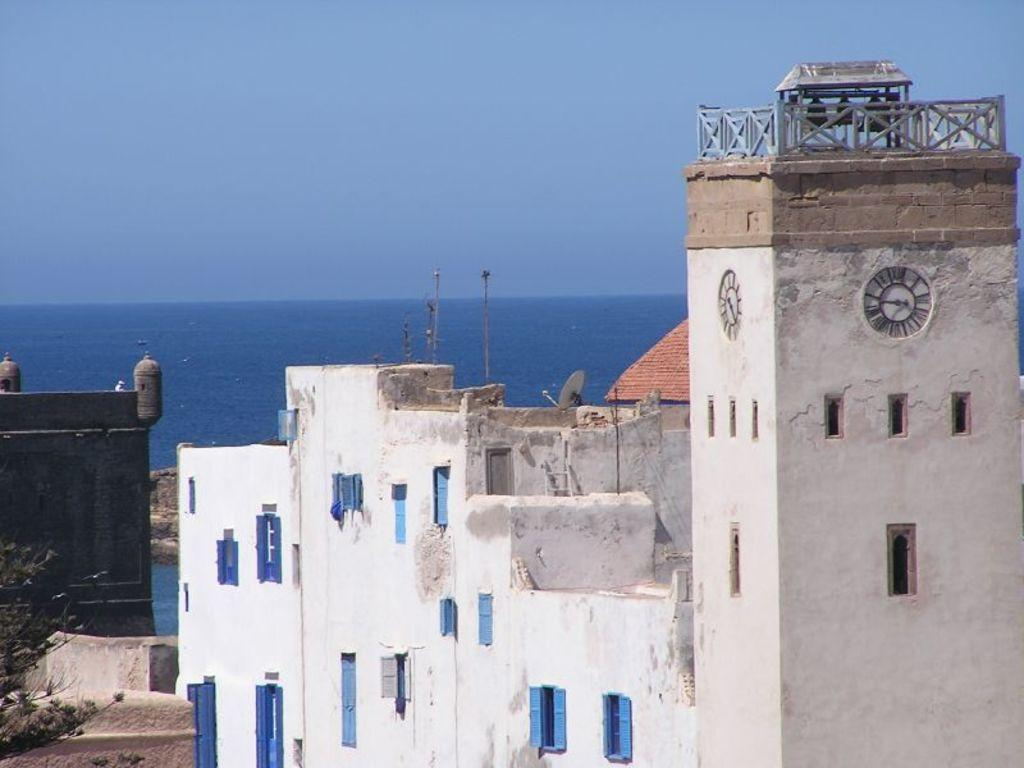What type of structures are present in the image? There is a group of buildings in the image. What natural feature can be seen in the background of the image? There is a sea visible in the background of the image. What type of skirt is being worn by the society in the image? There is no reference to a society or any individuals wearing skirts in the image. 